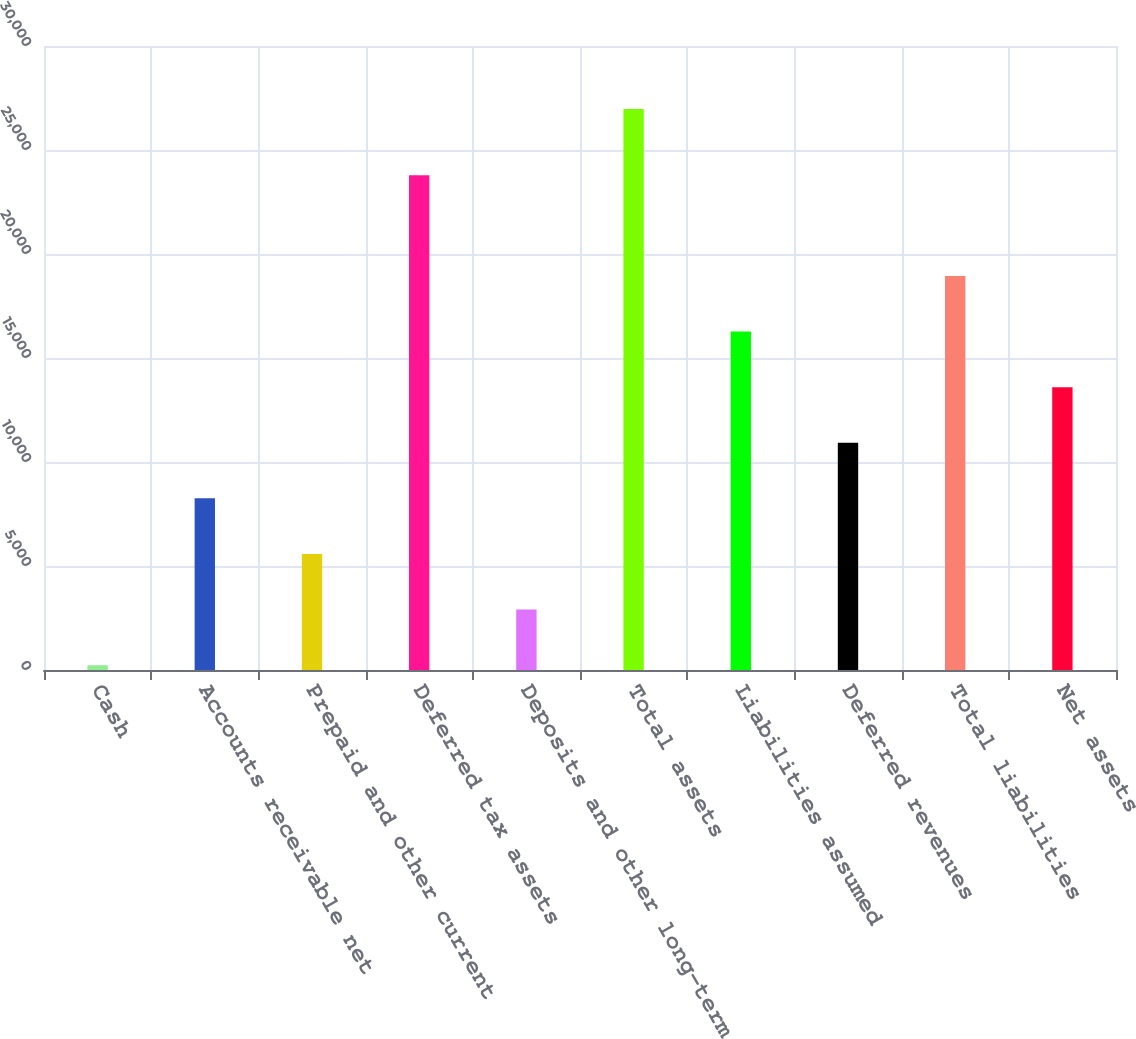Convert chart. <chart><loc_0><loc_0><loc_500><loc_500><bar_chart><fcel>Cash<fcel>Accounts receivable net<fcel>Prepaid and other current<fcel>Deferred tax assets<fcel>Deposits and other long-term<fcel>Total assets<fcel>Liabilities assumed<fcel>Deferred revenues<fcel>Total liabilities<fcel>Net assets<nl><fcel>229<fcel>8251.3<fcel>5577.2<fcel>23787<fcel>2903.1<fcel>26970<fcel>16273.6<fcel>10925.4<fcel>18947.7<fcel>13599.5<nl></chart> 